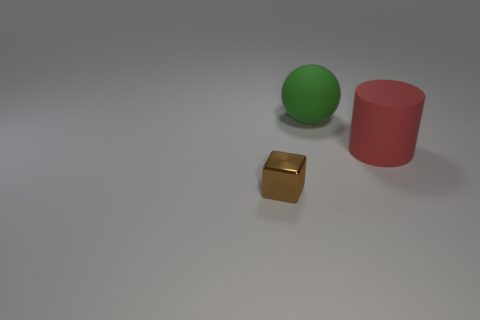Is the number of small rubber cylinders less than the number of big red matte objects?
Provide a succinct answer. Yes. Are there any other things that are the same size as the brown metallic cube?
Your response must be concise. No. Is the number of yellow metallic blocks greater than the number of red rubber things?
Keep it short and to the point. No. Are the large red cylinder and the big object left of the red matte cylinder made of the same material?
Ensure brevity in your answer.  Yes. There is a big thing that is behind the matte thing that is in front of the big green ball; how many big matte cylinders are on the right side of it?
Give a very brief answer. 1. Are there fewer big green rubber things left of the green matte ball than green rubber objects that are behind the red cylinder?
Make the answer very short. Yes. How many other things are there of the same material as the brown block?
Give a very brief answer. 0. What material is the green ball that is the same size as the cylinder?
Give a very brief answer. Rubber. How many cyan things are big cylinders or small objects?
Keep it short and to the point. 0. What color is the thing that is on the right side of the block and to the left of the red cylinder?
Ensure brevity in your answer.  Green. 